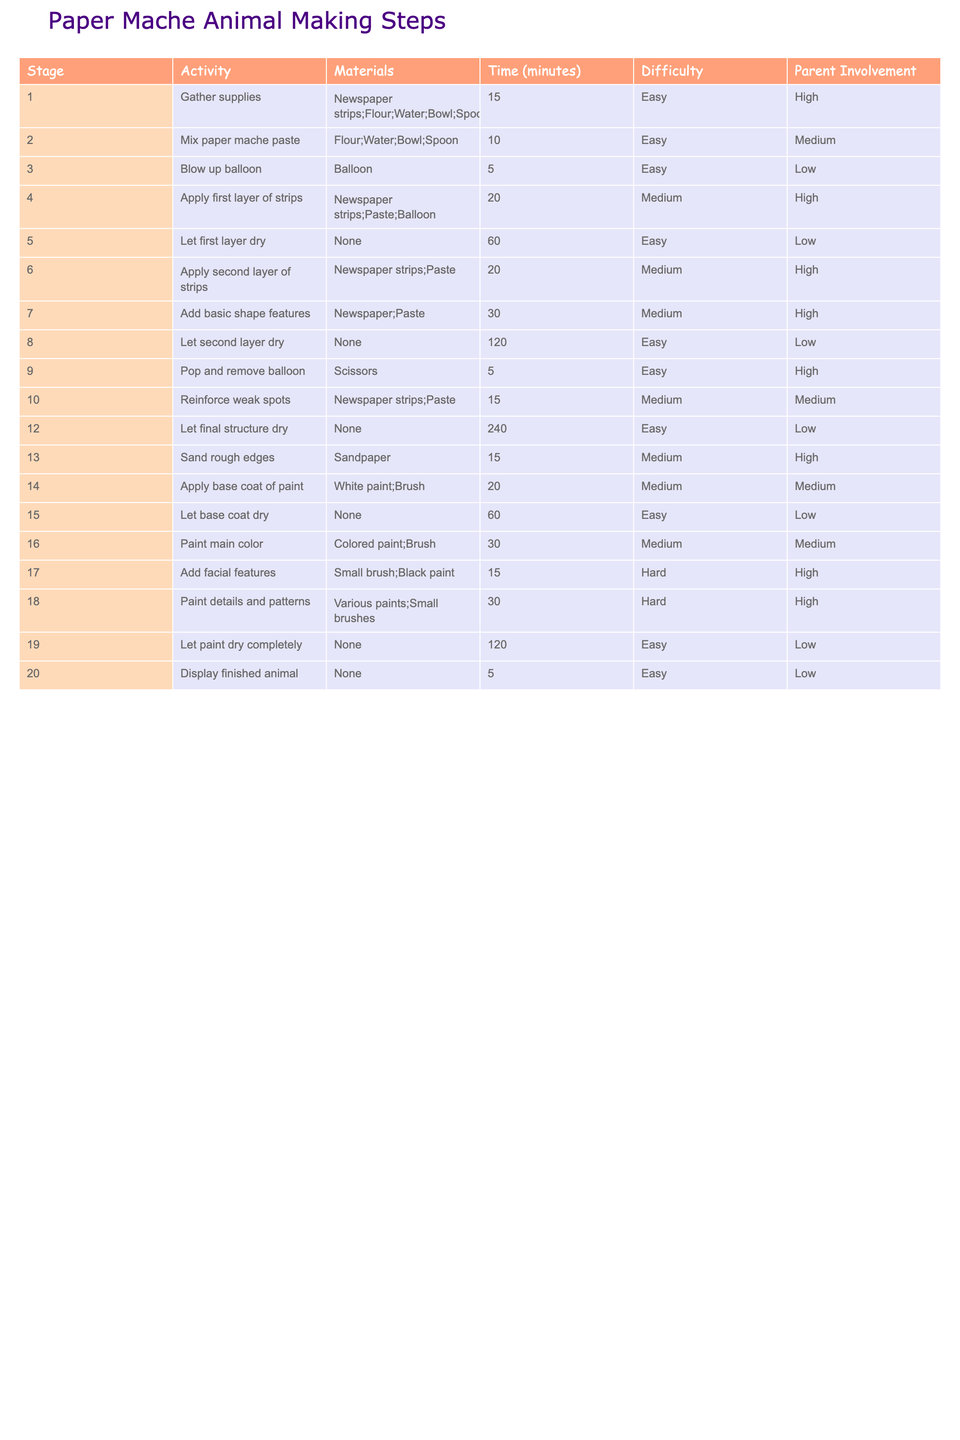What is the total time required to complete all the stages? To find the total time, I will add the time for each stage: 15 + 10 + 5 + 20 + 60 + 20 + 30 + 120 + 5 + 15 + 240 + 15 + 20 + 60 + 30 + 15 + 30 + 120 + 5 = 760
Answer: 760 Which stage requires the most involvement from a parent? The stages with high parent involvement include stages 1, 4, 6, 7, 9, 13, 17, and 18. From these, the most involvement is during stage 1 where it is marked as "High".
Answer: Stage 1 How many stages are labeled as "Easy"? I will count the stages labeled as "Easy". These are stages 1, 5, 8, 12, 15, 19, and 20, totaling 7 stages.
Answer: 7 Which activity has the longest drying time? I will look at the activities that mention drying time. There are two: stage 5 (60 minutes) and stage 12 (240 minutes). The longest is stage 12.
Answer: Stage 12 What is the average time taken for each stage? First, I sum the total time for all stages, which is 760 minutes, and since there are 20 stages, I divide 760 by 20, yielding an average of 38 minutes per stage.
Answer: 38 Is there any stage that does not require any materials? I will check each stage for the presence of materials. Stages 5, 8, 12, and 19 do not require any materials, therefore the answer is yes.
Answer: Yes What is the difference in time between the longest and shortest stages? The longest stage is stage 12 with 240 minutes, and the shortest is stage 3 with 5 minutes. The difference is 240 - 5 = 235 minutes.
Answer: 235 Which stage requires the most difficult challenge? I will check the difficulty levels of all stages. Stages 17 and 18 are Both marked as "Hard". The most difficult stages are these two.
Answer: Stage 17 and 18 How many total stages have a medium difficulty level? I will identify the medium difficulty stages: there are 4 stages (2, 4, 6, 10, 14, 16). Thus, there are 6 stages in total.
Answer: 6 In which stage do you add facial features to the animal? The stage where facial features are added is stage 17.
Answer: Stage 17 